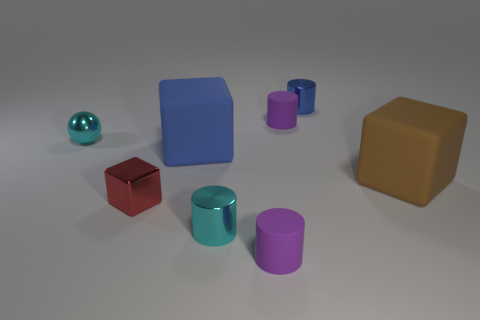There is a shiny sphere that is behind the big blue rubber block to the left of the rubber cylinder in front of the big brown rubber cube; how big is it?
Keep it short and to the point. Small. Is the blue object in front of the small blue object made of the same material as the small purple cylinder that is in front of the tiny red block?
Provide a succinct answer. Yes. What number of other objects are the same color as the small shiny block?
Your answer should be very brief. 0. How many objects are cylinders that are on the left side of the blue metallic cylinder or small cylinders that are in front of the tiny blue object?
Make the answer very short. 3. What size is the purple cylinder on the right side of the tiny purple thing that is in front of the tiny cyan metal cylinder?
Give a very brief answer. Small. How big is the red metal block?
Your answer should be compact. Small. There is a small matte thing that is in front of the brown matte block; is its color the same as the small metallic cylinder left of the tiny blue object?
Keep it short and to the point. No. How many other objects are the same material as the small red thing?
Give a very brief answer. 3. Are any tiny purple rubber things visible?
Provide a short and direct response. Yes. Are the cyan sphere to the left of the blue metallic object and the brown block made of the same material?
Your answer should be very brief. No. 